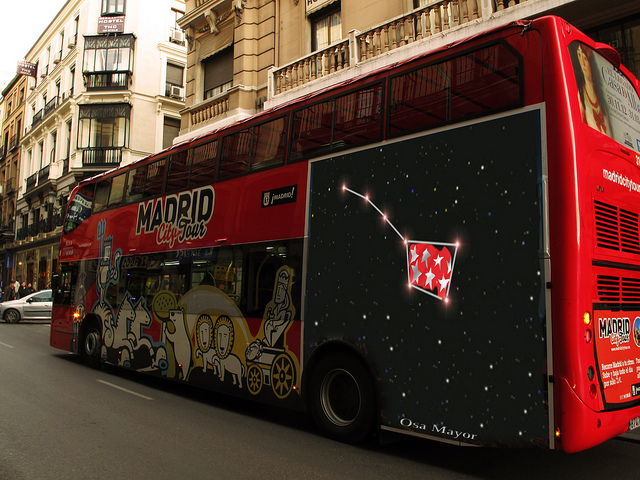Read and extract the text from this image. MADRID CITYTOUR MADRID OSA Mayor 